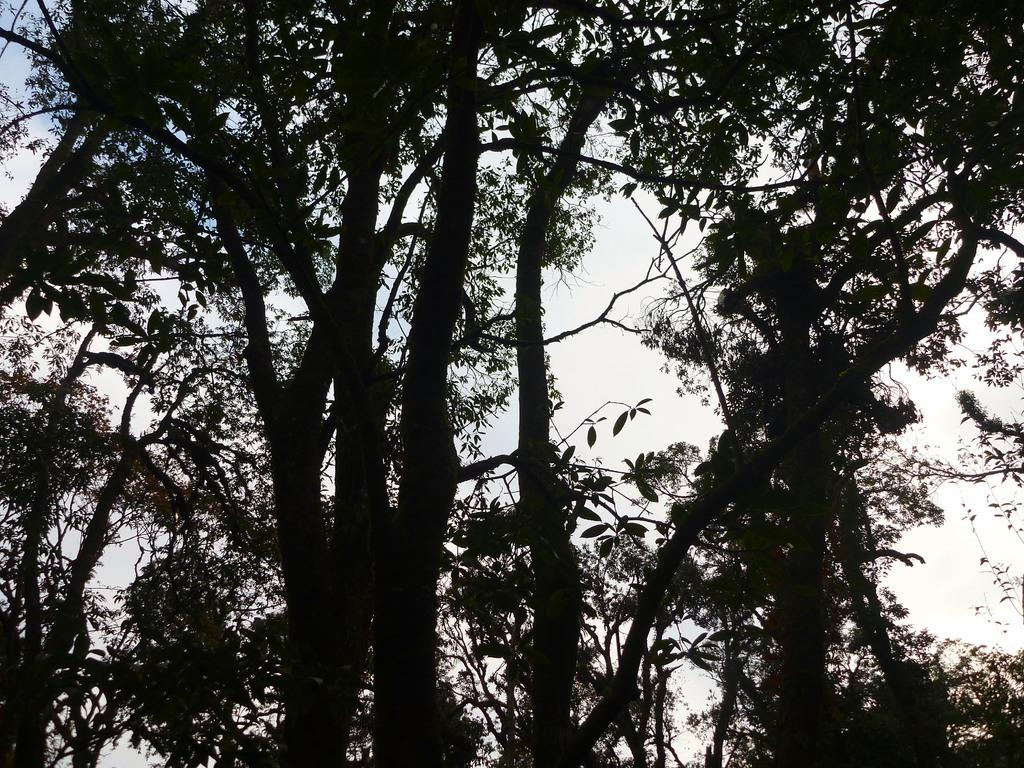What type of vegetation can be seen in the image? There are trees in the image. What part of the natural environment is visible in the image? The sky is visible in the background of the image. What type of neck accessory is visible on the trees in the image? There are no neck accessories present on the trees in the image. 